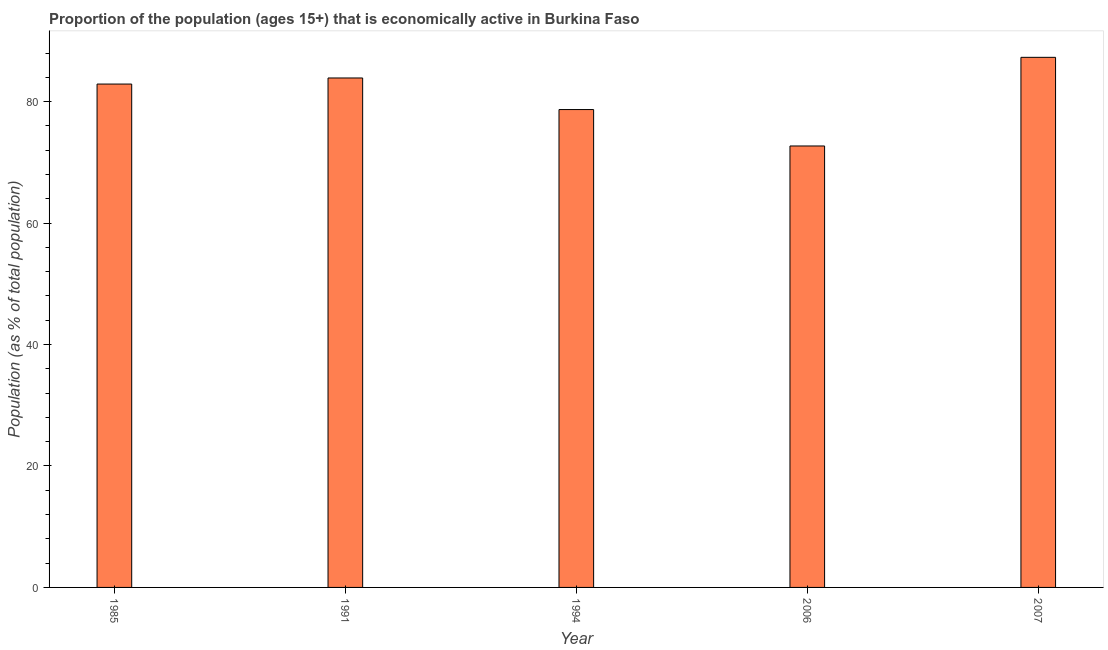Does the graph contain any zero values?
Your answer should be very brief. No. What is the title of the graph?
Ensure brevity in your answer.  Proportion of the population (ages 15+) that is economically active in Burkina Faso. What is the label or title of the X-axis?
Your answer should be compact. Year. What is the label or title of the Y-axis?
Provide a short and direct response. Population (as % of total population). What is the percentage of economically active population in 1985?
Your answer should be compact. 82.9. Across all years, what is the maximum percentage of economically active population?
Offer a very short reply. 87.3. Across all years, what is the minimum percentage of economically active population?
Provide a short and direct response. 72.7. In which year was the percentage of economically active population maximum?
Offer a very short reply. 2007. In which year was the percentage of economically active population minimum?
Your response must be concise. 2006. What is the sum of the percentage of economically active population?
Offer a very short reply. 405.5. What is the difference between the percentage of economically active population in 1985 and 1994?
Provide a succinct answer. 4.2. What is the average percentage of economically active population per year?
Keep it short and to the point. 81.1. What is the median percentage of economically active population?
Ensure brevity in your answer.  82.9. What is the ratio of the percentage of economically active population in 1991 to that in 1994?
Give a very brief answer. 1.07. Is the difference between the percentage of economically active population in 1994 and 2007 greater than the difference between any two years?
Ensure brevity in your answer.  No. What is the difference between the highest and the second highest percentage of economically active population?
Your answer should be compact. 3.4. How many bars are there?
Give a very brief answer. 5. Are all the bars in the graph horizontal?
Offer a very short reply. No. Are the values on the major ticks of Y-axis written in scientific E-notation?
Keep it short and to the point. No. What is the Population (as % of total population) in 1985?
Your answer should be compact. 82.9. What is the Population (as % of total population) of 1991?
Offer a terse response. 83.9. What is the Population (as % of total population) in 1994?
Provide a short and direct response. 78.7. What is the Population (as % of total population) of 2006?
Provide a short and direct response. 72.7. What is the Population (as % of total population) in 2007?
Ensure brevity in your answer.  87.3. What is the difference between the Population (as % of total population) in 1985 and 1994?
Offer a very short reply. 4.2. What is the difference between the Population (as % of total population) in 1991 and 2007?
Offer a very short reply. -3.4. What is the difference between the Population (as % of total population) in 1994 and 2006?
Provide a succinct answer. 6. What is the difference between the Population (as % of total population) in 1994 and 2007?
Your response must be concise. -8.6. What is the difference between the Population (as % of total population) in 2006 and 2007?
Provide a succinct answer. -14.6. What is the ratio of the Population (as % of total population) in 1985 to that in 1994?
Keep it short and to the point. 1.05. What is the ratio of the Population (as % of total population) in 1985 to that in 2006?
Give a very brief answer. 1.14. What is the ratio of the Population (as % of total population) in 1991 to that in 1994?
Offer a terse response. 1.07. What is the ratio of the Population (as % of total population) in 1991 to that in 2006?
Provide a short and direct response. 1.15. What is the ratio of the Population (as % of total population) in 1991 to that in 2007?
Make the answer very short. 0.96. What is the ratio of the Population (as % of total population) in 1994 to that in 2006?
Offer a terse response. 1.08. What is the ratio of the Population (as % of total population) in 1994 to that in 2007?
Ensure brevity in your answer.  0.9. What is the ratio of the Population (as % of total population) in 2006 to that in 2007?
Provide a succinct answer. 0.83. 